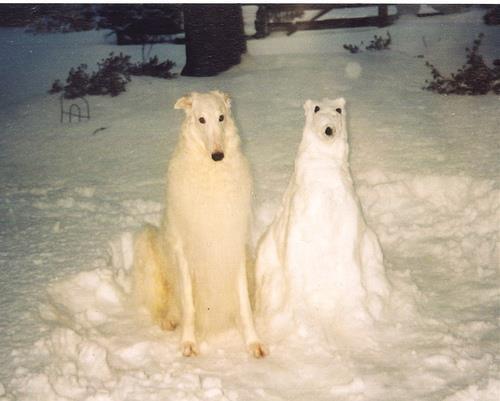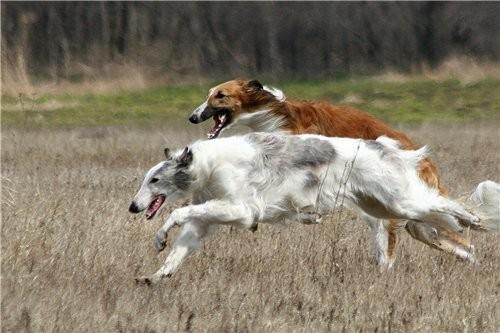The first image is the image on the left, the second image is the image on the right. Given the left and right images, does the statement "Each image depicts multiple hounds, and the right image includes at least one hound in a bounding pose." hold true? Answer yes or no. Yes. The first image is the image on the left, the second image is the image on the right. For the images shown, is this caption "Both images in the pair are paintings of dogs and not real dogs." true? Answer yes or no. No. 